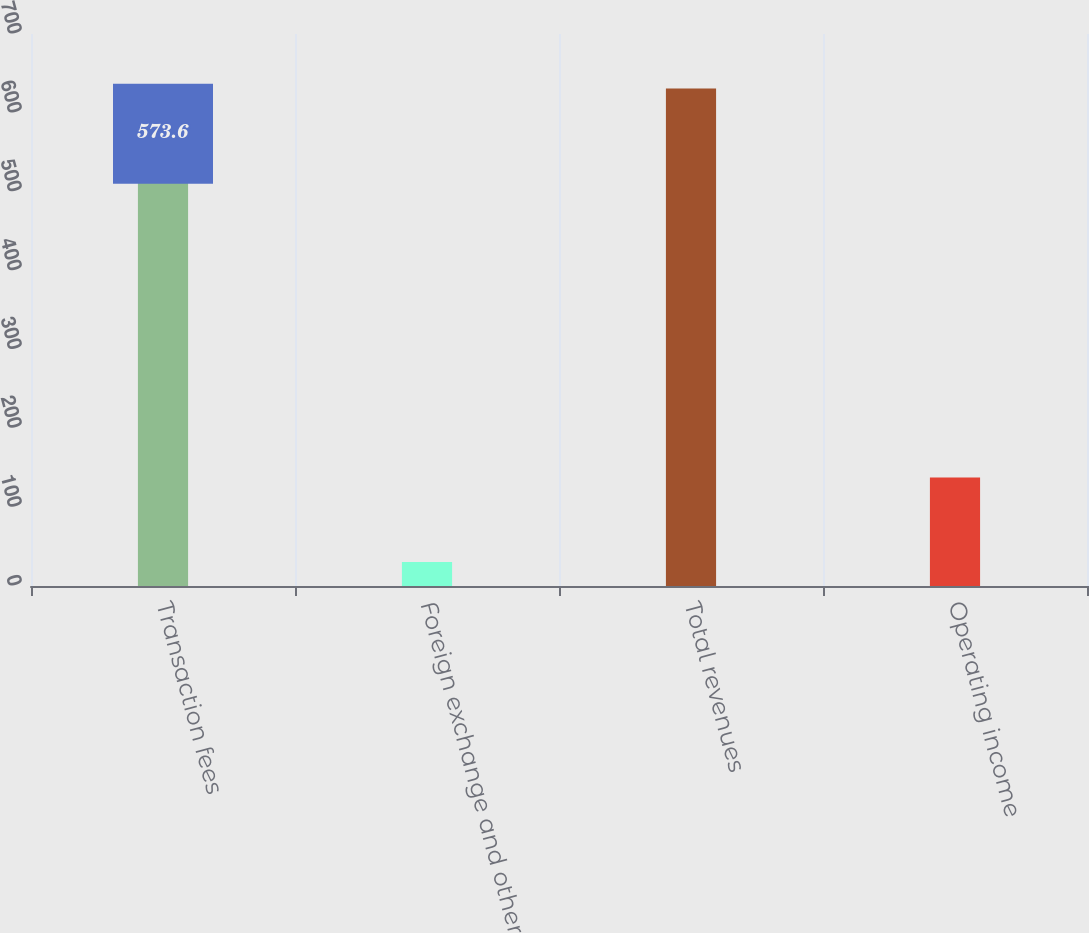Convert chart. <chart><loc_0><loc_0><loc_500><loc_500><bar_chart><fcel>Transaction fees<fcel>Foreign exchange and other<fcel>Total revenues<fcel>Operating income<nl><fcel>573.6<fcel>30.3<fcel>630.96<fcel>137.6<nl></chart> 